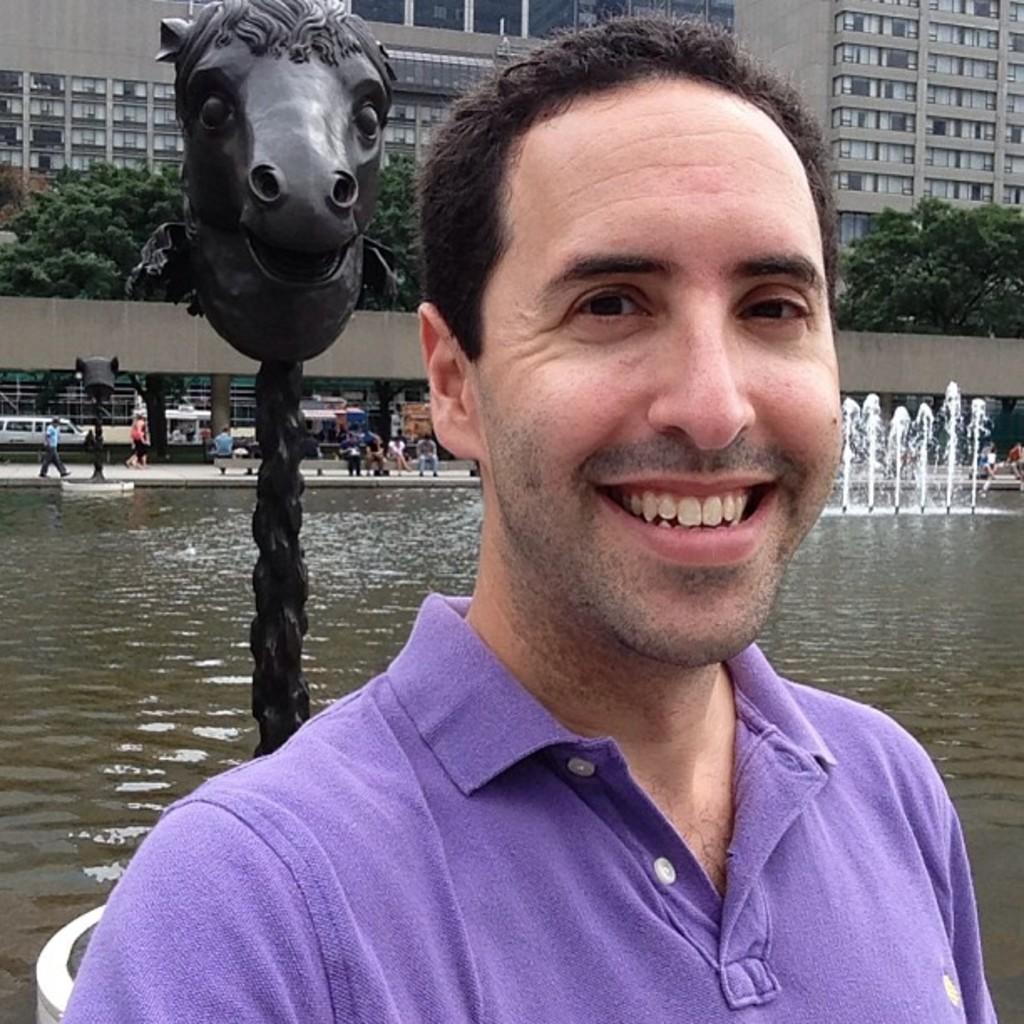Please provide a concise description of this image. In this image we can see a man and he is smiling. Here we can see water, poles, statue, fountain, people, wall, vehicle, and trees. In the background there are buildings. 